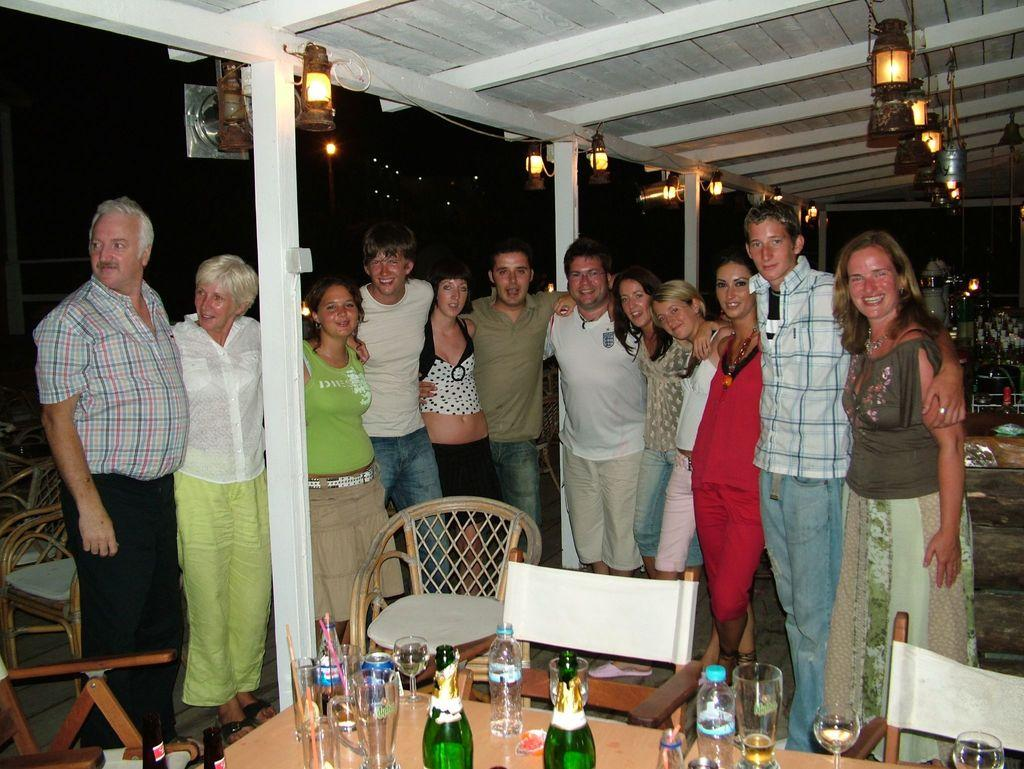How many people are in the group in the image? There is a group of people in the image, but the exact number is not specified. What is the facial expression of some people in the group? Some people in the group have smiles on their faces. What type of furniture is present in the image? There are chairs in the image. What type of tableware is present in the image? There are glasses in the image. What type of beverage containers are present in the image? There are bottles in the image. What can be seen in the background of the image? There are lights visible in the background of the image. What type of loaf is being served on the table in the image? There is no loaf present in the image. What type of animal can be seen interacting with the people in the image? There are no animals present in the image. 